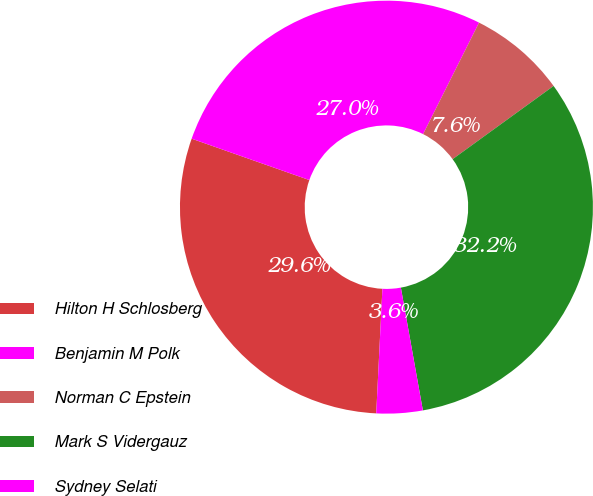<chart> <loc_0><loc_0><loc_500><loc_500><pie_chart><fcel>Hilton H Schlosberg<fcel>Benjamin M Polk<fcel>Norman C Epstein<fcel>Mark S Vidergauz<fcel>Sydney Selati<nl><fcel>29.59%<fcel>27.02%<fcel>7.61%<fcel>32.16%<fcel>3.61%<nl></chart> 